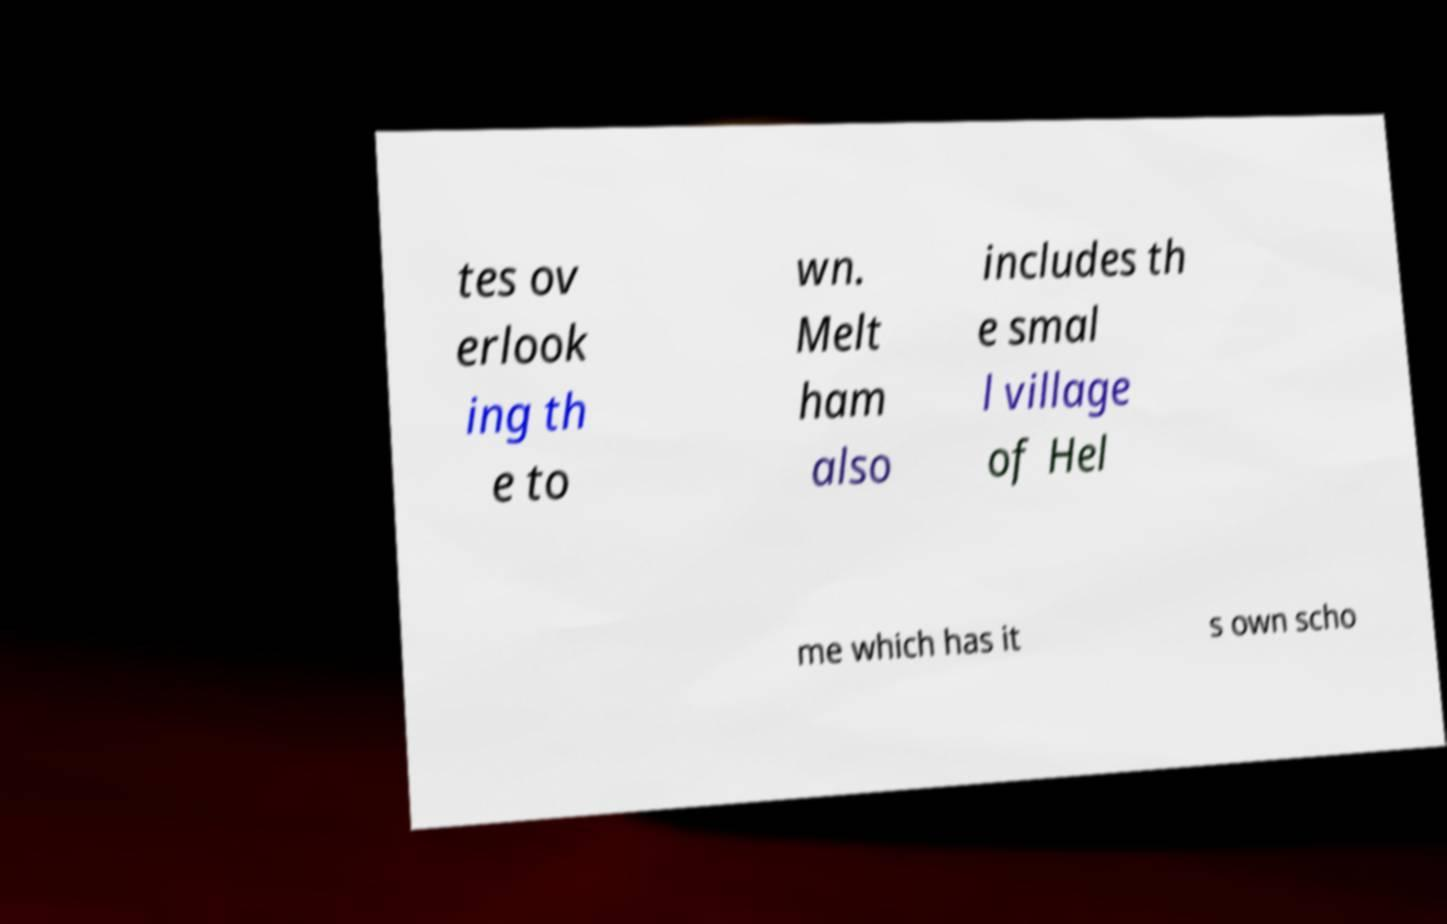Could you assist in decoding the text presented in this image and type it out clearly? tes ov erlook ing th e to wn. Melt ham also includes th e smal l village of Hel me which has it s own scho 